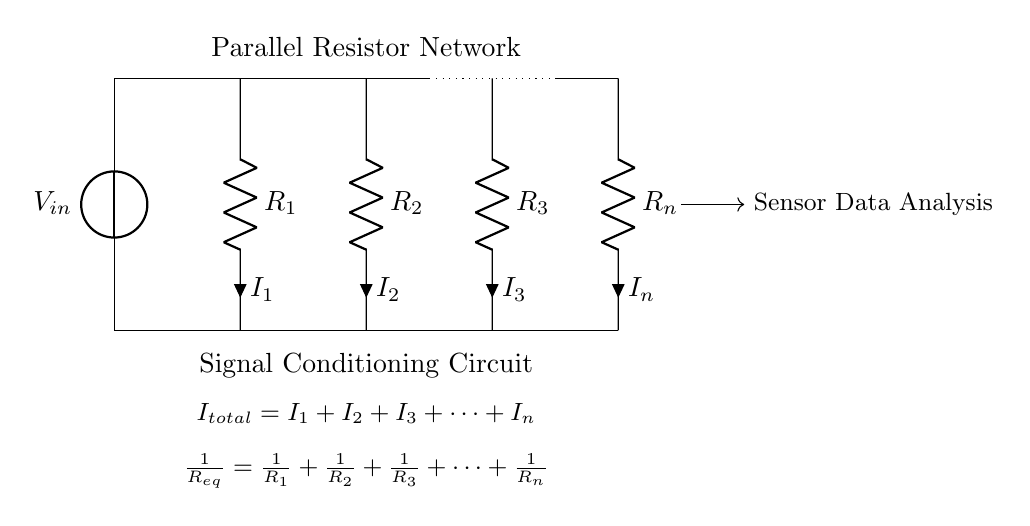What is the input voltage of the circuit? The input voltage is labeled as V in the circuit diagram. It is indicated on the voltage source at the top left corner of the diagram.
Answer: V in What type of circuit is shown in the diagram? The circuit is a parallel resistor network. This is evident from the arrangement of resistors that are connected side by side, allowing multiple current paths.
Answer: Parallel resistor network What is the relationship between the total current and the individual currents? The total current is the sum of all individual currents. This is stated in the equation below the circuit, indicating that I total equals I 1 plus I 2 plus I 3 and so on.
Answer: I total = I 1 + I 2 + I 3 + ... + I n What is the equivalent resistance formula for the resistors in this circuit? The equivalent resistance formula is displayed in the circuit diagram, stating that 1 over R eq equals 1 over R 1 plus 1 over R 2 plus 1 over R 3 and so forth. This shows how the resistances add inversely in parallel.
Answer: 1/R eq = 1/R 1 + 1/R 2 + 1/R 3 + ... + 1/R n If R 1, R 2, and R 3 have values of 10 ohms, 20 ohms, and 30 ohms, respectively, what is the equivalent resistance of the network? To find the equivalent resistance, use the formula for parallel resistances: 1/R eq = 1/10 + 1/20 + 1/30. First, calculate the fractions: 1/10 = 0.1, 1/20 = 0.05, 1/30 ≈ 0.0333. Then, sum these to get approximately 0.1833; taking the reciprocal gives R eq ≈ 5.45 ohms.
Answer: 5.45 ohms 